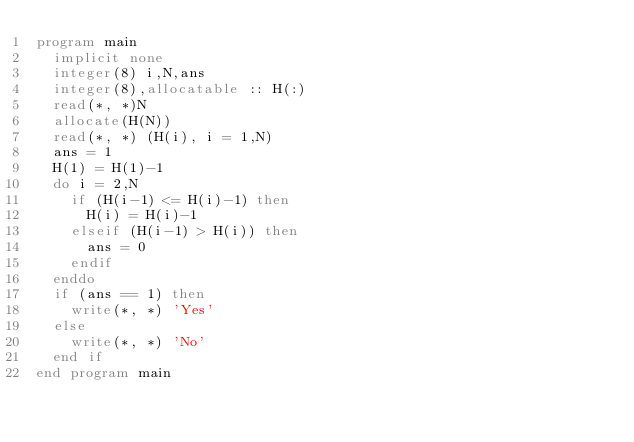<code> <loc_0><loc_0><loc_500><loc_500><_FORTRAN_>program main
  implicit none
  integer(8) i,N,ans
  integer(8),allocatable :: H(:)
  read(*, *)N
  allocate(H(N))
  read(*, *) (H(i), i = 1,N)
  ans = 1
  H(1) = H(1)-1
  do i = 2,N
    if (H(i-1) <= H(i)-1) then
      H(i) = H(i)-1
    elseif (H(i-1) > H(i)) then
      ans = 0
    endif
  enddo
  if (ans == 1) then
    write(*, *) 'Yes'
  else
    write(*, *) 'No'
  end if
end program main
</code> 